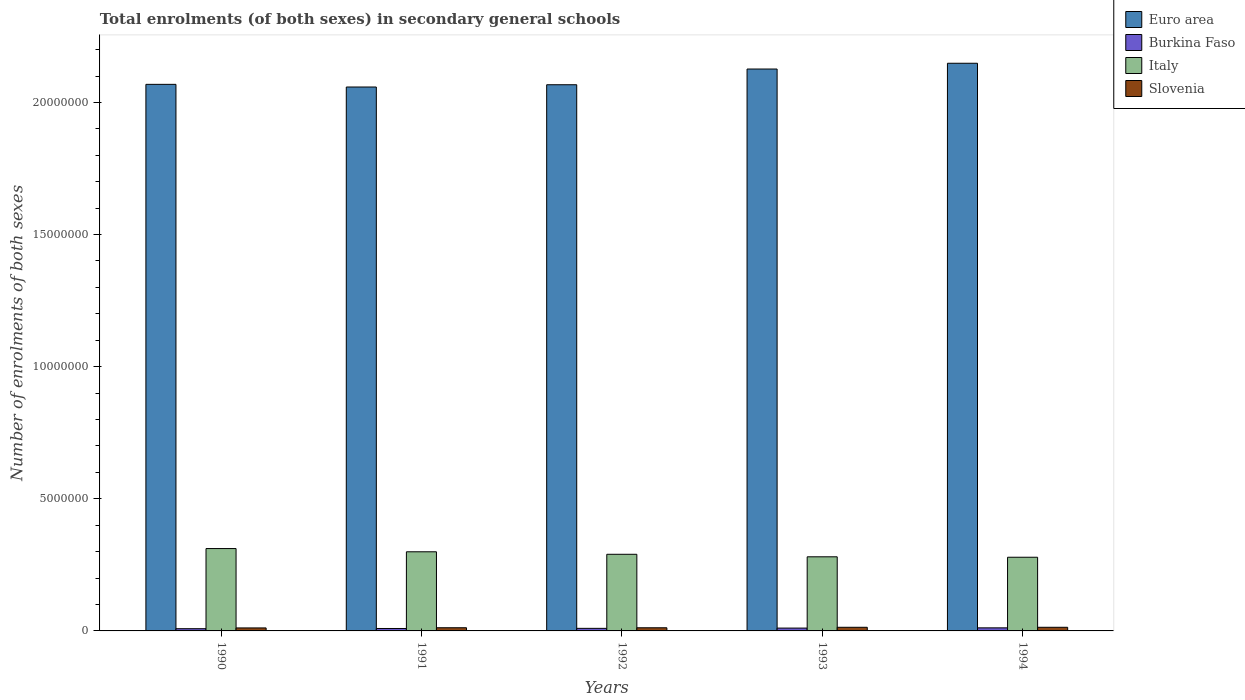How many different coloured bars are there?
Offer a very short reply. 4. Are the number of bars per tick equal to the number of legend labels?
Ensure brevity in your answer.  Yes. Are the number of bars on each tick of the X-axis equal?
Your answer should be compact. Yes. What is the label of the 4th group of bars from the left?
Offer a very short reply. 1993. In how many cases, is the number of bars for a given year not equal to the number of legend labels?
Provide a succinct answer. 0. What is the number of enrolments in secondary schools in Italy in 1993?
Provide a succinct answer. 2.81e+06. Across all years, what is the maximum number of enrolments in secondary schools in Euro area?
Provide a succinct answer. 2.15e+07. Across all years, what is the minimum number of enrolments in secondary schools in Euro area?
Your answer should be very brief. 2.06e+07. In which year was the number of enrolments in secondary schools in Euro area minimum?
Give a very brief answer. 1991. What is the total number of enrolments in secondary schools in Italy in the graph?
Offer a very short reply. 1.46e+07. What is the difference between the number of enrolments in secondary schools in Euro area in 1991 and that in 1993?
Give a very brief answer. -6.81e+05. What is the difference between the number of enrolments in secondary schools in Burkina Faso in 1993 and the number of enrolments in secondary schools in Slovenia in 1990?
Your answer should be compact. -6480. What is the average number of enrolments in secondary schools in Italy per year?
Your answer should be compact. 2.92e+06. In the year 1992, what is the difference between the number of enrolments in secondary schools in Euro area and number of enrolments in secondary schools in Italy?
Provide a short and direct response. 1.78e+07. What is the ratio of the number of enrolments in secondary schools in Italy in 1991 to that in 1994?
Your answer should be very brief. 1.07. Is the number of enrolments in secondary schools in Euro area in 1991 less than that in 1992?
Your response must be concise. Yes. Is the difference between the number of enrolments in secondary schools in Euro area in 1990 and 1992 greater than the difference between the number of enrolments in secondary schools in Italy in 1990 and 1992?
Keep it short and to the point. No. What is the difference between the highest and the second highest number of enrolments in secondary schools in Italy?
Make the answer very short. 1.22e+05. What is the difference between the highest and the lowest number of enrolments in secondary schools in Slovenia?
Provide a succinct answer. 2.41e+04. In how many years, is the number of enrolments in secondary schools in Slovenia greater than the average number of enrolments in secondary schools in Slovenia taken over all years?
Offer a very short reply. 2. What does the 1st bar from the left in 1991 represents?
Ensure brevity in your answer.  Euro area. What does the 1st bar from the right in 1991 represents?
Offer a terse response. Slovenia. Is it the case that in every year, the sum of the number of enrolments in secondary schools in Slovenia and number of enrolments in secondary schools in Burkina Faso is greater than the number of enrolments in secondary schools in Italy?
Give a very brief answer. No. How many bars are there?
Keep it short and to the point. 20. Are all the bars in the graph horizontal?
Your answer should be very brief. No. How many years are there in the graph?
Offer a terse response. 5. Are the values on the major ticks of Y-axis written in scientific E-notation?
Ensure brevity in your answer.  No. Where does the legend appear in the graph?
Ensure brevity in your answer.  Top right. How are the legend labels stacked?
Your answer should be very brief. Vertical. What is the title of the graph?
Keep it short and to the point. Total enrolments (of both sexes) in secondary general schools. What is the label or title of the X-axis?
Your answer should be very brief. Years. What is the label or title of the Y-axis?
Give a very brief answer. Number of enrolments of both sexes. What is the Number of enrolments of both sexes of Euro area in 1990?
Offer a very short reply. 2.07e+07. What is the Number of enrolments of both sexes in Burkina Faso in 1990?
Your answer should be compact. 8.42e+04. What is the Number of enrolments of both sexes of Italy in 1990?
Your answer should be very brief. 3.12e+06. What is the Number of enrolments of both sexes in Slovenia in 1990?
Provide a succinct answer. 1.14e+05. What is the Number of enrolments of both sexes in Euro area in 1991?
Your answer should be compact. 2.06e+07. What is the Number of enrolments of both sexes in Burkina Faso in 1991?
Offer a very short reply. 9.17e+04. What is the Number of enrolments of both sexes of Italy in 1991?
Provide a succinct answer. 2.99e+06. What is the Number of enrolments of both sexes of Slovenia in 1991?
Make the answer very short. 1.20e+05. What is the Number of enrolments of both sexes of Euro area in 1992?
Your response must be concise. 2.07e+07. What is the Number of enrolments of both sexes of Burkina Faso in 1992?
Keep it short and to the point. 9.72e+04. What is the Number of enrolments of both sexes of Italy in 1992?
Make the answer very short. 2.90e+06. What is the Number of enrolments of both sexes of Slovenia in 1992?
Provide a short and direct response. 1.19e+05. What is the Number of enrolments of both sexes in Euro area in 1993?
Make the answer very short. 2.13e+07. What is the Number of enrolments of both sexes in Burkina Faso in 1993?
Give a very brief answer. 1.07e+05. What is the Number of enrolments of both sexes in Italy in 1993?
Give a very brief answer. 2.81e+06. What is the Number of enrolments of both sexes in Slovenia in 1993?
Your answer should be compact. 1.37e+05. What is the Number of enrolments of both sexes of Euro area in 1994?
Give a very brief answer. 2.15e+07. What is the Number of enrolments of both sexes of Burkina Faso in 1994?
Provide a short and direct response. 1.16e+05. What is the Number of enrolments of both sexes in Italy in 1994?
Keep it short and to the point. 2.79e+06. What is the Number of enrolments of both sexes in Slovenia in 1994?
Give a very brief answer. 1.38e+05. Across all years, what is the maximum Number of enrolments of both sexes of Euro area?
Your answer should be compact. 2.15e+07. Across all years, what is the maximum Number of enrolments of both sexes in Burkina Faso?
Provide a short and direct response. 1.16e+05. Across all years, what is the maximum Number of enrolments of both sexes in Italy?
Your answer should be very brief. 3.12e+06. Across all years, what is the maximum Number of enrolments of both sexes of Slovenia?
Make the answer very short. 1.38e+05. Across all years, what is the minimum Number of enrolments of both sexes of Euro area?
Your answer should be very brief. 2.06e+07. Across all years, what is the minimum Number of enrolments of both sexes in Burkina Faso?
Offer a terse response. 8.42e+04. Across all years, what is the minimum Number of enrolments of both sexes of Italy?
Provide a short and direct response. 2.79e+06. Across all years, what is the minimum Number of enrolments of both sexes in Slovenia?
Offer a very short reply. 1.14e+05. What is the total Number of enrolments of both sexes of Euro area in the graph?
Your response must be concise. 1.05e+08. What is the total Number of enrolments of both sexes of Burkina Faso in the graph?
Ensure brevity in your answer.  4.96e+05. What is the total Number of enrolments of both sexes in Italy in the graph?
Keep it short and to the point. 1.46e+07. What is the total Number of enrolments of both sexes in Slovenia in the graph?
Your answer should be compact. 6.28e+05. What is the difference between the Number of enrolments of both sexes in Euro area in 1990 and that in 1991?
Your answer should be very brief. 1.01e+05. What is the difference between the Number of enrolments of both sexes of Burkina Faso in 1990 and that in 1991?
Keep it short and to the point. -7494. What is the difference between the Number of enrolments of both sexes of Italy in 1990 and that in 1991?
Make the answer very short. 1.22e+05. What is the difference between the Number of enrolments of both sexes in Slovenia in 1990 and that in 1991?
Your answer should be very brief. -6898. What is the difference between the Number of enrolments of both sexes of Euro area in 1990 and that in 1992?
Give a very brief answer. 1.49e+04. What is the difference between the Number of enrolments of both sexes in Burkina Faso in 1990 and that in 1992?
Your answer should be very brief. -1.29e+04. What is the difference between the Number of enrolments of both sexes of Italy in 1990 and that in 1992?
Make the answer very short. 2.17e+05. What is the difference between the Number of enrolments of both sexes in Slovenia in 1990 and that in 1992?
Keep it short and to the point. -5394. What is the difference between the Number of enrolments of both sexes in Euro area in 1990 and that in 1993?
Give a very brief answer. -5.80e+05. What is the difference between the Number of enrolments of both sexes of Burkina Faso in 1990 and that in 1993?
Offer a very short reply. -2.28e+04. What is the difference between the Number of enrolments of both sexes in Italy in 1990 and that in 1993?
Offer a terse response. 3.12e+05. What is the difference between the Number of enrolments of both sexes of Slovenia in 1990 and that in 1993?
Your answer should be very brief. -2.39e+04. What is the difference between the Number of enrolments of both sexes in Euro area in 1990 and that in 1994?
Make the answer very short. -7.98e+05. What is the difference between the Number of enrolments of both sexes in Burkina Faso in 1990 and that in 1994?
Your answer should be very brief. -3.18e+04. What is the difference between the Number of enrolments of both sexes in Italy in 1990 and that in 1994?
Your response must be concise. 3.28e+05. What is the difference between the Number of enrolments of both sexes in Slovenia in 1990 and that in 1994?
Make the answer very short. -2.41e+04. What is the difference between the Number of enrolments of both sexes of Euro area in 1991 and that in 1992?
Offer a terse response. -8.61e+04. What is the difference between the Number of enrolments of both sexes of Burkina Faso in 1991 and that in 1992?
Offer a terse response. -5443. What is the difference between the Number of enrolments of both sexes of Italy in 1991 and that in 1992?
Your response must be concise. 9.48e+04. What is the difference between the Number of enrolments of both sexes in Slovenia in 1991 and that in 1992?
Keep it short and to the point. 1504. What is the difference between the Number of enrolments of both sexes in Euro area in 1991 and that in 1993?
Your response must be concise. -6.81e+05. What is the difference between the Number of enrolments of both sexes in Burkina Faso in 1991 and that in 1993?
Provide a short and direct response. -1.53e+04. What is the difference between the Number of enrolments of both sexes in Italy in 1991 and that in 1993?
Keep it short and to the point. 1.90e+05. What is the difference between the Number of enrolments of both sexes in Slovenia in 1991 and that in 1993?
Ensure brevity in your answer.  -1.70e+04. What is the difference between the Number of enrolments of both sexes in Euro area in 1991 and that in 1994?
Provide a succinct answer. -8.99e+05. What is the difference between the Number of enrolments of both sexes of Burkina Faso in 1991 and that in 1994?
Your answer should be compact. -2.43e+04. What is the difference between the Number of enrolments of both sexes of Italy in 1991 and that in 1994?
Provide a short and direct response. 2.06e+05. What is the difference between the Number of enrolments of both sexes of Slovenia in 1991 and that in 1994?
Provide a succinct answer. -1.72e+04. What is the difference between the Number of enrolments of both sexes in Euro area in 1992 and that in 1993?
Keep it short and to the point. -5.95e+05. What is the difference between the Number of enrolments of both sexes of Burkina Faso in 1992 and that in 1993?
Your answer should be compact. -9854. What is the difference between the Number of enrolments of both sexes of Italy in 1992 and that in 1993?
Keep it short and to the point. 9.50e+04. What is the difference between the Number of enrolments of both sexes of Slovenia in 1992 and that in 1993?
Provide a short and direct response. -1.85e+04. What is the difference between the Number of enrolments of both sexes in Euro area in 1992 and that in 1994?
Ensure brevity in your answer.  -8.13e+05. What is the difference between the Number of enrolments of both sexes of Burkina Faso in 1992 and that in 1994?
Your answer should be compact. -1.89e+04. What is the difference between the Number of enrolments of both sexes in Italy in 1992 and that in 1994?
Your answer should be very brief. 1.11e+05. What is the difference between the Number of enrolments of both sexes in Slovenia in 1992 and that in 1994?
Offer a very short reply. -1.87e+04. What is the difference between the Number of enrolments of both sexes in Euro area in 1993 and that in 1994?
Your answer should be very brief. -2.18e+05. What is the difference between the Number of enrolments of both sexes of Burkina Faso in 1993 and that in 1994?
Your answer should be compact. -9009. What is the difference between the Number of enrolments of both sexes in Italy in 1993 and that in 1994?
Ensure brevity in your answer.  1.65e+04. What is the difference between the Number of enrolments of both sexes in Slovenia in 1993 and that in 1994?
Your response must be concise. -164. What is the difference between the Number of enrolments of both sexes in Euro area in 1990 and the Number of enrolments of both sexes in Burkina Faso in 1991?
Make the answer very short. 2.06e+07. What is the difference between the Number of enrolments of both sexes in Euro area in 1990 and the Number of enrolments of both sexes in Italy in 1991?
Give a very brief answer. 1.77e+07. What is the difference between the Number of enrolments of both sexes of Euro area in 1990 and the Number of enrolments of both sexes of Slovenia in 1991?
Your answer should be very brief. 2.06e+07. What is the difference between the Number of enrolments of both sexes in Burkina Faso in 1990 and the Number of enrolments of both sexes in Italy in 1991?
Ensure brevity in your answer.  -2.91e+06. What is the difference between the Number of enrolments of both sexes of Burkina Faso in 1990 and the Number of enrolments of both sexes of Slovenia in 1991?
Keep it short and to the point. -3.62e+04. What is the difference between the Number of enrolments of both sexes in Italy in 1990 and the Number of enrolments of both sexes in Slovenia in 1991?
Make the answer very short. 3.00e+06. What is the difference between the Number of enrolments of both sexes of Euro area in 1990 and the Number of enrolments of both sexes of Burkina Faso in 1992?
Offer a very short reply. 2.06e+07. What is the difference between the Number of enrolments of both sexes in Euro area in 1990 and the Number of enrolments of both sexes in Italy in 1992?
Offer a terse response. 1.78e+07. What is the difference between the Number of enrolments of both sexes of Euro area in 1990 and the Number of enrolments of both sexes of Slovenia in 1992?
Provide a short and direct response. 2.06e+07. What is the difference between the Number of enrolments of both sexes in Burkina Faso in 1990 and the Number of enrolments of both sexes in Italy in 1992?
Provide a succinct answer. -2.82e+06. What is the difference between the Number of enrolments of both sexes in Burkina Faso in 1990 and the Number of enrolments of both sexes in Slovenia in 1992?
Your response must be concise. -3.47e+04. What is the difference between the Number of enrolments of both sexes in Italy in 1990 and the Number of enrolments of both sexes in Slovenia in 1992?
Provide a succinct answer. 3.00e+06. What is the difference between the Number of enrolments of both sexes of Euro area in 1990 and the Number of enrolments of both sexes of Burkina Faso in 1993?
Your answer should be compact. 2.06e+07. What is the difference between the Number of enrolments of both sexes of Euro area in 1990 and the Number of enrolments of both sexes of Italy in 1993?
Keep it short and to the point. 1.79e+07. What is the difference between the Number of enrolments of both sexes of Euro area in 1990 and the Number of enrolments of both sexes of Slovenia in 1993?
Make the answer very short. 2.05e+07. What is the difference between the Number of enrolments of both sexes in Burkina Faso in 1990 and the Number of enrolments of both sexes in Italy in 1993?
Offer a terse response. -2.72e+06. What is the difference between the Number of enrolments of both sexes in Burkina Faso in 1990 and the Number of enrolments of both sexes in Slovenia in 1993?
Provide a succinct answer. -5.32e+04. What is the difference between the Number of enrolments of both sexes of Italy in 1990 and the Number of enrolments of both sexes of Slovenia in 1993?
Provide a short and direct response. 2.98e+06. What is the difference between the Number of enrolments of both sexes of Euro area in 1990 and the Number of enrolments of both sexes of Burkina Faso in 1994?
Make the answer very short. 2.06e+07. What is the difference between the Number of enrolments of both sexes of Euro area in 1990 and the Number of enrolments of both sexes of Italy in 1994?
Give a very brief answer. 1.79e+07. What is the difference between the Number of enrolments of both sexes in Euro area in 1990 and the Number of enrolments of both sexes in Slovenia in 1994?
Your answer should be very brief. 2.05e+07. What is the difference between the Number of enrolments of both sexes in Burkina Faso in 1990 and the Number of enrolments of both sexes in Italy in 1994?
Provide a short and direct response. -2.70e+06. What is the difference between the Number of enrolments of both sexes in Burkina Faso in 1990 and the Number of enrolments of both sexes in Slovenia in 1994?
Make the answer very short. -5.33e+04. What is the difference between the Number of enrolments of both sexes of Italy in 1990 and the Number of enrolments of both sexes of Slovenia in 1994?
Your response must be concise. 2.98e+06. What is the difference between the Number of enrolments of both sexes of Euro area in 1991 and the Number of enrolments of both sexes of Burkina Faso in 1992?
Offer a very short reply. 2.05e+07. What is the difference between the Number of enrolments of both sexes of Euro area in 1991 and the Number of enrolments of both sexes of Italy in 1992?
Give a very brief answer. 1.77e+07. What is the difference between the Number of enrolments of both sexes in Euro area in 1991 and the Number of enrolments of both sexes in Slovenia in 1992?
Ensure brevity in your answer.  2.05e+07. What is the difference between the Number of enrolments of both sexes in Burkina Faso in 1991 and the Number of enrolments of both sexes in Italy in 1992?
Provide a short and direct response. -2.81e+06. What is the difference between the Number of enrolments of both sexes in Burkina Faso in 1991 and the Number of enrolments of both sexes in Slovenia in 1992?
Your answer should be compact. -2.72e+04. What is the difference between the Number of enrolments of both sexes in Italy in 1991 and the Number of enrolments of both sexes in Slovenia in 1992?
Your response must be concise. 2.88e+06. What is the difference between the Number of enrolments of both sexes of Euro area in 1991 and the Number of enrolments of both sexes of Burkina Faso in 1993?
Make the answer very short. 2.05e+07. What is the difference between the Number of enrolments of both sexes of Euro area in 1991 and the Number of enrolments of both sexes of Italy in 1993?
Ensure brevity in your answer.  1.78e+07. What is the difference between the Number of enrolments of both sexes of Euro area in 1991 and the Number of enrolments of both sexes of Slovenia in 1993?
Offer a very short reply. 2.04e+07. What is the difference between the Number of enrolments of both sexes in Burkina Faso in 1991 and the Number of enrolments of both sexes in Italy in 1993?
Your response must be concise. -2.71e+06. What is the difference between the Number of enrolments of both sexes of Burkina Faso in 1991 and the Number of enrolments of both sexes of Slovenia in 1993?
Keep it short and to the point. -4.57e+04. What is the difference between the Number of enrolments of both sexes in Italy in 1991 and the Number of enrolments of both sexes in Slovenia in 1993?
Keep it short and to the point. 2.86e+06. What is the difference between the Number of enrolments of both sexes in Euro area in 1991 and the Number of enrolments of both sexes in Burkina Faso in 1994?
Give a very brief answer. 2.05e+07. What is the difference between the Number of enrolments of both sexes of Euro area in 1991 and the Number of enrolments of both sexes of Italy in 1994?
Provide a succinct answer. 1.78e+07. What is the difference between the Number of enrolments of both sexes of Euro area in 1991 and the Number of enrolments of both sexes of Slovenia in 1994?
Your response must be concise. 2.04e+07. What is the difference between the Number of enrolments of both sexes in Burkina Faso in 1991 and the Number of enrolments of both sexes in Italy in 1994?
Your answer should be compact. -2.70e+06. What is the difference between the Number of enrolments of both sexes in Burkina Faso in 1991 and the Number of enrolments of both sexes in Slovenia in 1994?
Your answer should be compact. -4.59e+04. What is the difference between the Number of enrolments of both sexes in Italy in 1991 and the Number of enrolments of both sexes in Slovenia in 1994?
Give a very brief answer. 2.86e+06. What is the difference between the Number of enrolments of both sexes of Euro area in 1992 and the Number of enrolments of both sexes of Burkina Faso in 1993?
Provide a succinct answer. 2.06e+07. What is the difference between the Number of enrolments of both sexes in Euro area in 1992 and the Number of enrolments of both sexes in Italy in 1993?
Give a very brief answer. 1.79e+07. What is the difference between the Number of enrolments of both sexes of Euro area in 1992 and the Number of enrolments of both sexes of Slovenia in 1993?
Offer a terse response. 2.05e+07. What is the difference between the Number of enrolments of both sexes of Burkina Faso in 1992 and the Number of enrolments of both sexes of Italy in 1993?
Your answer should be compact. -2.71e+06. What is the difference between the Number of enrolments of both sexes in Burkina Faso in 1992 and the Number of enrolments of both sexes in Slovenia in 1993?
Ensure brevity in your answer.  -4.02e+04. What is the difference between the Number of enrolments of both sexes in Italy in 1992 and the Number of enrolments of both sexes in Slovenia in 1993?
Your response must be concise. 2.76e+06. What is the difference between the Number of enrolments of both sexes of Euro area in 1992 and the Number of enrolments of both sexes of Burkina Faso in 1994?
Provide a short and direct response. 2.06e+07. What is the difference between the Number of enrolments of both sexes of Euro area in 1992 and the Number of enrolments of both sexes of Italy in 1994?
Keep it short and to the point. 1.79e+07. What is the difference between the Number of enrolments of both sexes in Euro area in 1992 and the Number of enrolments of both sexes in Slovenia in 1994?
Give a very brief answer. 2.05e+07. What is the difference between the Number of enrolments of both sexes of Burkina Faso in 1992 and the Number of enrolments of both sexes of Italy in 1994?
Your response must be concise. -2.69e+06. What is the difference between the Number of enrolments of both sexes in Burkina Faso in 1992 and the Number of enrolments of both sexes in Slovenia in 1994?
Offer a very short reply. -4.04e+04. What is the difference between the Number of enrolments of both sexes in Italy in 1992 and the Number of enrolments of both sexes in Slovenia in 1994?
Offer a terse response. 2.76e+06. What is the difference between the Number of enrolments of both sexes in Euro area in 1993 and the Number of enrolments of both sexes in Burkina Faso in 1994?
Ensure brevity in your answer.  2.11e+07. What is the difference between the Number of enrolments of both sexes in Euro area in 1993 and the Number of enrolments of both sexes in Italy in 1994?
Your answer should be very brief. 1.85e+07. What is the difference between the Number of enrolments of both sexes of Euro area in 1993 and the Number of enrolments of both sexes of Slovenia in 1994?
Offer a very short reply. 2.11e+07. What is the difference between the Number of enrolments of both sexes of Burkina Faso in 1993 and the Number of enrolments of both sexes of Italy in 1994?
Your response must be concise. -2.68e+06. What is the difference between the Number of enrolments of both sexes in Burkina Faso in 1993 and the Number of enrolments of both sexes in Slovenia in 1994?
Offer a terse response. -3.06e+04. What is the difference between the Number of enrolments of both sexes in Italy in 1993 and the Number of enrolments of both sexes in Slovenia in 1994?
Provide a succinct answer. 2.67e+06. What is the average Number of enrolments of both sexes of Euro area per year?
Your response must be concise. 2.09e+07. What is the average Number of enrolments of both sexes of Burkina Faso per year?
Your response must be concise. 9.92e+04. What is the average Number of enrolments of both sexes in Italy per year?
Your response must be concise. 2.92e+06. What is the average Number of enrolments of both sexes in Slovenia per year?
Your answer should be very brief. 1.26e+05. In the year 1990, what is the difference between the Number of enrolments of both sexes of Euro area and Number of enrolments of both sexes of Burkina Faso?
Give a very brief answer. 2.06e+07. In the year 1990, what is the difference between the Number of enrolments of both sexes in Euro area and Number of enrolments of both sexes in Italy?
Offer a very short reply. 1.76e+07. In the year 1990, what is the difference between the Number of enrolments of both sexes in Euro area and Number of enrolments of both sexes in Slovenia?
Provide a short and direct response. 2.06e+07. In the year 1990, what is the difference between the Number of enrolments of both sexes of Burkina Faso and Number of enrolments of both sexes of Italy?
Provide a succinct answer. -3.03e+06. In the year 1990, what is the difference between the Number of enrolments of both sexes of Burkina Faso and Number of enrolments of both sexes of Slovenia?
Offer a terse response. -2.93e+04. In the year 1990, what is the difference between the Number of enrolments of both sexes in Italy and Number of enrolments of both sexes in Slovenia?
Your response must be concise. 3.00e+06. In the year 1991, what is the difference between the Number of enrolments of both sexes in Euro area and Number of enrolments of both sexes in Burkina Faso?
Make the answer very short. 2.05e+07. In the year 1991, what is the difference between the Number of enrolments of both sexes in Euro area and Number of enrolments of both sexes in Italy?
Your answer should be compact. 1.76e+07. In the year 1991, what is the difference between the Number of enrolments of both sexes in Euro area and Number of enrolments of both sexes in Slovenia?
Provide a short and direct response. 2.05e+07. In the year 1991, what is the difference between the Number of enrolments of both sexes of Burkina Faso and Number of enrolments of both sexes of Italy?
Provide a short and direct response. -2.90e+06. In the year 1991, what is the difference between the Number of enrolments of both sexes of Burkina Faso and Number of enrolments of both sexes of Slovenia?
Your response must be concise. -2.87e+04. In the year 1991, what is the difference between the Number of enrolments of both sexes in Italy and Number of enrolments of both sexes in Slovenia?
Give a very brief answer. 2.87e+06. In the year 1992, what is the difference between the Number of enrolments of both sexes of Euro area and Number of enrolments of both sexes of Burkina Faso?
Provide a succinct answer. 2.06e+07. In the year 1992, what is the difference between the Number of enrolments of both sexes of Euro area and Number of enrolments of both sexes of Italy?
Make the answer very short. 1.78e+07. In the year 1992, what is the difference between the Number of enrolments of both sexes of Euro area and Number of enrolments of both sexes of Slovenia?
Your response must be concise. 2.06e+07. In the year 1992, what is the difference between the Number of enrolments of both sexes in Burkina Faso and Number of enrolments of both sexes in Italy?
Ensure brevity in your answer.  -2.80e+06. In the year 1992, what is the difference between the Number of enrolments of both sexes of Burkina Faso and Number of enrolments of both sexes of Slovenia?
Offer a terse response. -2.17e+04. In the year 1992, what is the difference between the Number of enrolments of both sexes of Italy and Number of enrolments of both sexes of Slovenia?
Your answer should be compact. 2.78e+06. In the year 1993, what is the difference between the Number of enrolments of both sexes in Euro area and Number of enrolments of both sexes in Burkina Faso?
Ensure brevity in your answer.  2.12e+07. In the year 1993, what is the difference between the Number of enrolments of both sexes of Euro area and Number of enrolments of both sexes of Italy?
Provide a succinct answer. 1.85e+07. In the year 1993, what is the difference between the Number of enrolments of both sexes in Euro area and Number of enrolments of both sexes in Slovenia?
Make the answer very short. 2.11e+07. In the year 1993, what is the difference between the Number of enrolments of both sexes in Burkina Faso and Number of enrolments of both sexes in Italy?
Offer a terse response. -2.70e+06. In the year 1993, what is the difference between the Number of enrolments of both sexes in Burkina Faso and Number of enrolments of both sexes in Slovenia?
Keep it short and to the point. -3.04e+04. In the year 1993, what is the difference between the Number of enrolments of both sexes of Italy and Number of enrolments of both sexes of Slovenia?
Offer a very short reply. 2.67e+06. In the year 1994, what is the difference between the Number of enrolments of both sexes of Euro area and Number of enrolments of both sexes of Burkina Faso?
Your answer should be very brief. 2.14e+07. In the year 1994, what is the difference between the Number of enrolments of both sexes of Euro area and Number of enrolments of both sexes of Italy?
Make the answer very short. 1.87e+07. In the year 1994, what is the difference between the Number of enrolments of both sexes of Euro area and Number of enrolments of both sexes of Slovenia?
Your response must be concise. 2.13e+07. In the year 1994, what is the difference between the Number of enrolments of both sexes of Burkina Faso and Number of enrolments of both sexes of Italy?
Keep it short and to the point. -2.67e+06. In the year 1994, what is the difference between the Number of enrolments of both sexes of Burkina Faso and Number of enrolments of both sexes of Slovenia?
Your response must be concise. -2.15e+04. In the year 1994, what is the difference between the Number of enrolments of both sexes in Italy and Number of enrolments of both sexes in Slovenia?
Keep it short and to the point. 2.65e+06. What is the ratio of the Number of enrolments of both sexes in Euro area in 1990 to that in 1991?
Offer a terse response. 1. What is the ratio of the Number of enrolments of both sexes in Burkina Faso in 1990 to that in 1991?
Keep it short and to the point. 0.92. What is the ratio of the Number of enrolments of both sexes in Italy in 1990 to that in 1991?
Give a very brief answer. 1.04. What is the ratio of the Number of enrolments of both sexes in Slovenia in 1990 to that in 1991?
Your response must be concise. 0.94. What is the ratio of the Number of enrolments of both sexes in Burkina Faso in 1990 to that in 1992?
Provide a succinct answer. 0.87. What is the ratio of the Number of enrolments of both sexes in Italy in 1990 to that in 1992?
Ensure brevity in your answer.  1.07. What is the ratio of the Number of enrolments of both sexes in Slovenia in 1990 to that in 1992?
Offer a very short reply. 0.95. What is the ratio of the Number of enrolments of both sexes of Euro area in 1990 to that in 1993?
Your answer should be compact. 0.97. What is the ratio of the Number of enrolments of both sexes in Burkina Faso in 1990 to that in 1993?
Offer a very short reply. 0.79. What is the ratio of the Number of enrolments of both sexes of Italy in 1990 to that in 1993?
Make the answer very short. 1.11. What is the ratio of the Number of enrolments of both sexes of Slovenia in 1990 to that in 1993?
Offer a very short reply. 0.83. What is the ratio of the Number of enrolments of both sexes in Euro area in 1990 to that in 1994?
Keep it short and to the point. 0.96. What is the ratio of the Number of enrolments of both sexes of Burkina Faso in 1990 to that in 1994?
Your answer should be very brief. 0.73. What is the ratio of the Number of enrolments of both sexes of Italy in 1990 to that in 1994?
Keep it short and to the point. 1.12. What is the ratio of the Number of enrolments of both sexes of Slovenia in 1990 to that in 1994?
Give a very brief answer. 0.82. What is the ratio of the Number of enrolments of both sexes of Burkina Faso in 1991 to that in 1992?
Ensure brevity in your answer.  0.94. What is the ratio of the Number of enrolments of both sexes of Italy in 1991 to that in 1992?
Make the answer very short. 1.03. What is the ratio of the Number of enrolments of both sexes in Slovenia in 1991 to that in 1992?
Keep it short and to the point. 1.01. What is the ratio of the Number of enrolments of both sexes of Burkina Faso in 1991 to that in 1993?
Your answer should be very brief. 0.86. What is the ratio of the Number of enrolments of both sexes in Italy in 1991 to that in 1993?
Offer a terse response. 1.07. What is the ratio of the Number of enrolments of both sexes of Slovenia in 1991 to that in 1993?
Your response must be concise. 0.88. What is the ratio of the Number of enrolments of both sexes of Euro area in 1991 to that in 1994?
Make the answer very short. 0.96. What is the ratio of the Number of enrolments of both sexes in Burkina Faso in 1991 to that in 1994?
Provide a short and direct response. 0.79. What is the ratio of the Number of enrolments of both sexes of Italy in 1991 to that in 1994?
Provide a short and direct response. 1.07. What is the ratio of the Number of enrolments of both sexes in Slovenia in 1991 to that in 1994?
Give a very brief answer. 0.88. What is the ratio of the Number of enrolments of both sexes of Euro area in 1992 to that in 1993?
Give a very brief answer. 0.97. What is the ratio of the Number of enrolments of both sexes in Burkina Faso in 1992 to that in 1993?
Your answer should be very brief. 0.91. What is the ratio of the Number of enrolments of both sexes in Italy in 1992 to that in 1993?
Your answer should be very brief. 1.03. What is the ratio of the Number of enrolments of both sexes of Slovenia in 1992 to that in 1993?
Make the answer very short. 0.87. What is the ratio of the Number of enrolments of both sexes in Euro area in 1992 to that in 1994?
Keep it short and to the point. 0.96. What is the ratio of the Number of enrolments of both sexes in Burkina Faso in 1992 to that in 1994?
Give a very brief answer. 0.84. What is the ratio of the Number of enrolments of both sexes in Italy in 1992 to that in 1994?
Provide a succinct answer. 1.04. What is the ratio of the Number of enrolments of both sexes in Slovenia in 1992 to that in 1994?
Your answer should be compact. 0.86. What is the ratio of the Number of enrolments of both sexes of Euro area in 1993 to that in 1994?
Offer a very short reply. 0.99. What is the ratio of the Number of enrolments of both sexes in Burkina Faso in 1993 to that in 1994?
Provide a short and direct response. 0.92. What is the ratio of the Number of enrolments of both sexes in Italy in 1993 to that in 1994?
Offer a very short reply. 1.01. What is the difference between the highest and the second highest Number of enrolments of both sexes of Euro area?
Give a very brief answer. 2.18e+05. What is the difference between the highest and the second highest Number of enrolments of both sexes in Burkina Faso?
Make the answer very short. 9009. What is the difference between the highest and the second highest Number of enrolments of both sexes in Italy?
Your response must be concise. 1.22e+05. What is the difference between the highest and the second highest Number of enrolments of both sexes of Slovenia?
Offer a very short reply. 164. What is the difference between the highest and the lowest Number of enrolments of both sexes of Euro area?
Make the answer very short. 8.99e+05. What is the difference between the highest and the lowest Number of enrolments of both sexes in Burkina Faso?
Provide a succinct answer. 3.18e+04. What is the difference between the highest and the lowest Number of enrolments of both sexes of Italy?
Offer a terse response. 3.28e+05. What is the difference between the highest and the lowest Number of enrolments of both sexes of Slovenia?
Provide a short and direct response. 2.41e+04. 